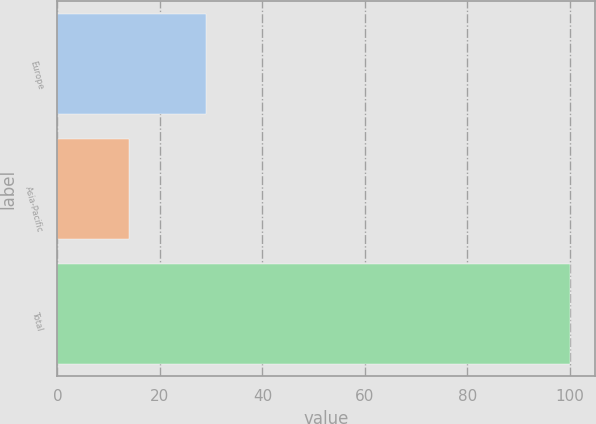Convert chart. <chart><loc_0><loc_0><loc_500><loc_500><bar_chart><fcel>Europe<fcel>Asia-Pacific<fcel>Total<nl><fcel>29<fcel>14<fcel>100<nl></chart> 